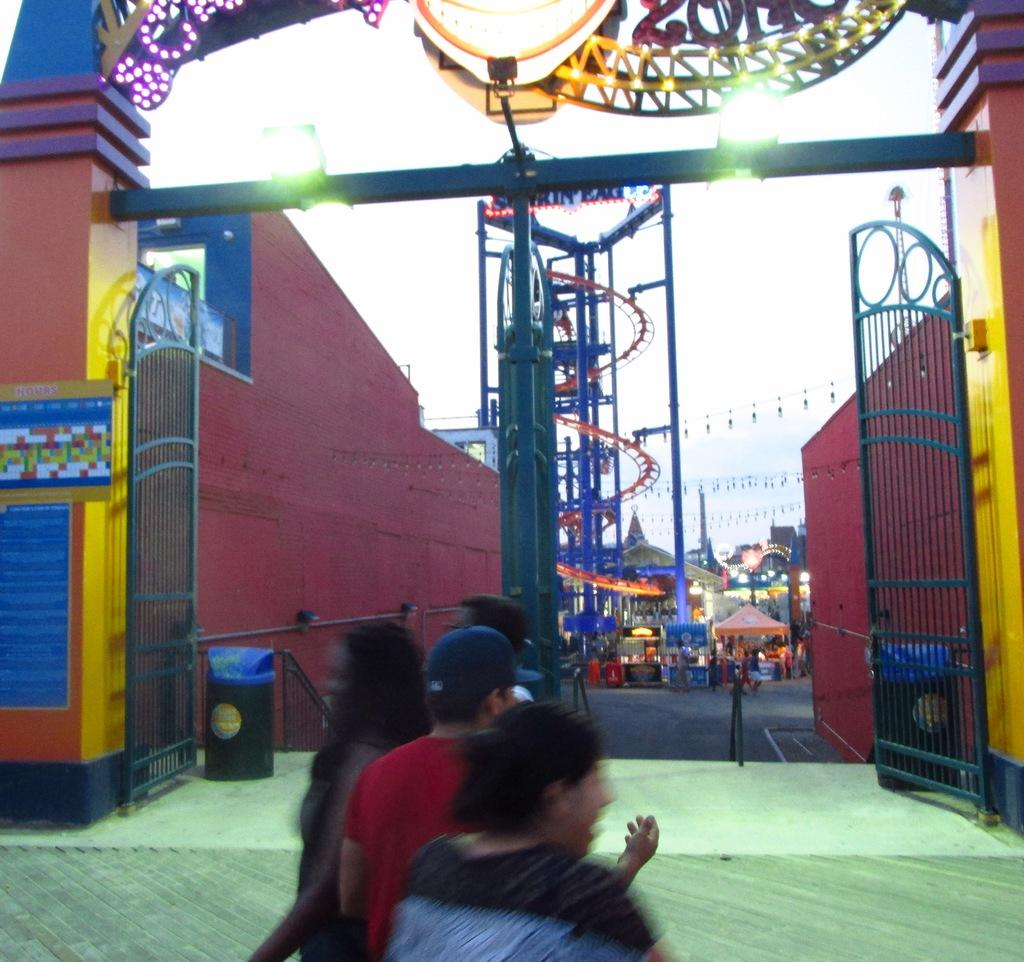Who or what can be seen in the image? There are people in the image. What structures are present in the image? There are gates, walls, and stalls in the image. What additional features can be observed? There are lights and other objects in the image. What can be seen in the background of the image? The sky is visible in the background of the image. What type of toy is being used by the people in the image? There is no toy present in the image. What is the tendency of the gates in the image? The gates in the image do not have a tendency, as they are stationary structures. 